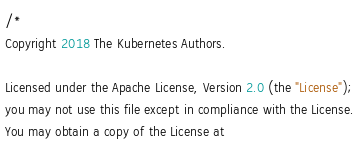<code> <loc_0><loc_0><loc_500><loc_500><_Go_>/*
Copyright 2018 The Kubernetes Authors.

Licensed under the Apache License, Version 2.0 (the "License");
you may not use this file except in compliance with the License.
You may obtain a copy of the License at
</code> 